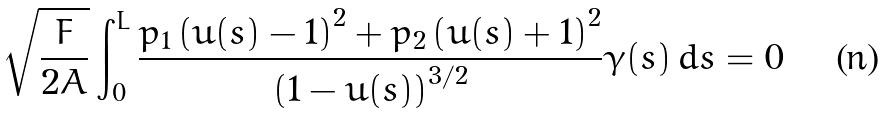Convert formula to latex. <formula><loc_0><loc_0><loc_500><loc_500>\sqrt { \frac { F } { 2 A } } \int _ { 0 } ^ { L } \frac { p _ { 1 } \left ( u ( s ) - 1 \right ) ^ { 2 } + p _ { 2 } \left ( u ( s ) + 1 \right ) ^ { 2 } } { \left ( 1 - u ( s ) \right ) ^ { 3 / 2 } } \gamma ( s ) \, d s = 0</formula> 